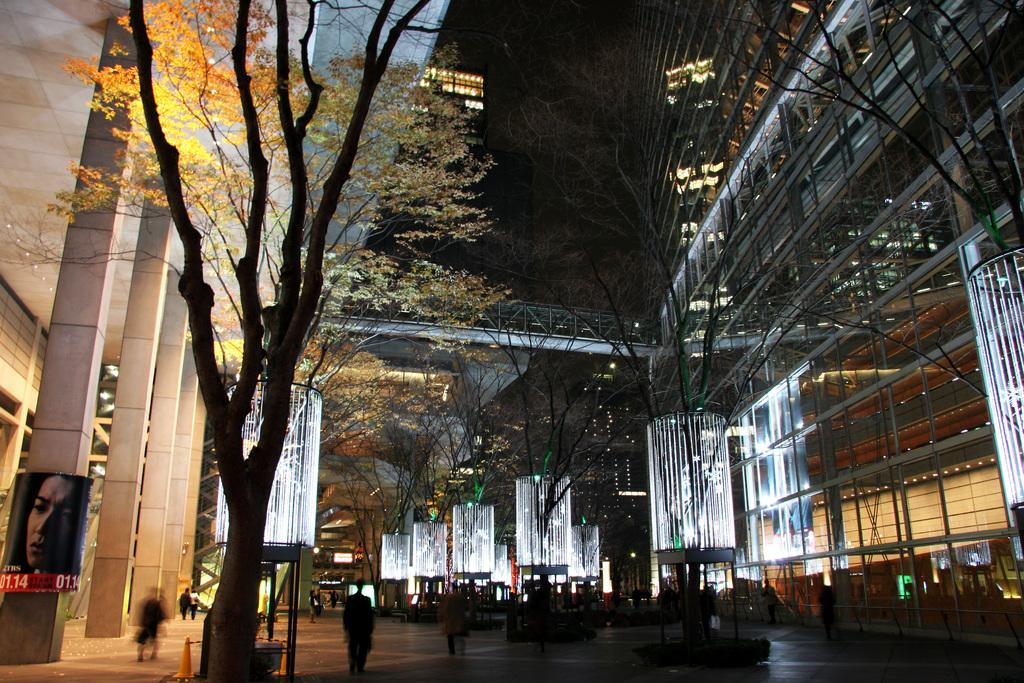What is located on the left side of the image? There is a tree on the left side of the image. Can you describe any other objects or features in the image? Yes, there is a poster on a pillar in the bottom left corner of the image. How many friends are visible in the image? There are no friends visible in the image; it only features a tree and a poster on a pillar. What type of paper is the poster made of in the image? The fact provided does not mention the type of paper the poster is made of, so we cannot determine that information from the image. 